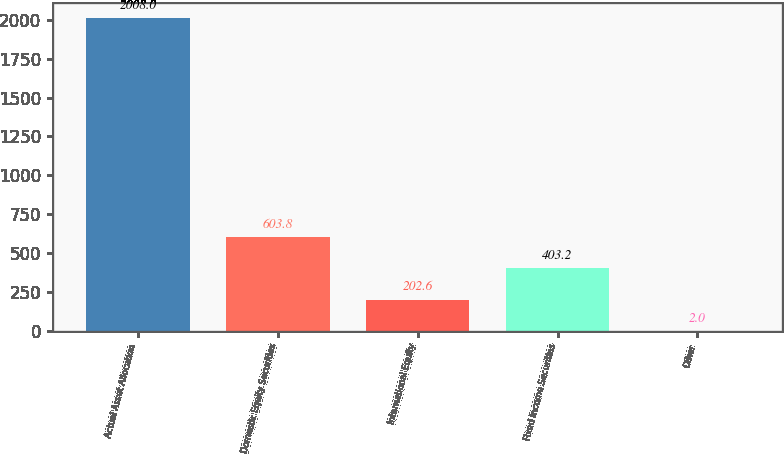Convert chart to OTSL. <chart><loc_0><loc_0><loc_500><loc_500><bar_chart><fcel>Actual Asset Allocation<fcel>Domestic Equity Securities<fcel>International Equity<fcel>Fixed Income Securities<fcel>Other<nl><fcel>2008<fcel>603.8<fcel>202.6<fcel>403.2<fcel>2<nl></chart> 